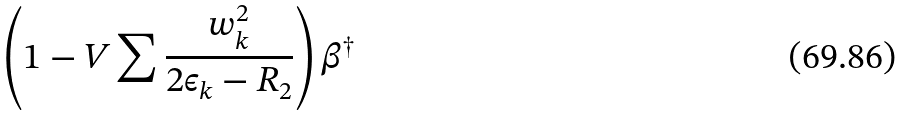Convert formula to latex. <formula><loc_0><loc_0><loc_500><loc_500>\left ( 1 - V \sum \frac { w _ { k } ^ { 2 } } { 2 \epsilon _ { k } - R _ { 2 } } \right ) \beta ^ { \dagger }</formula> 